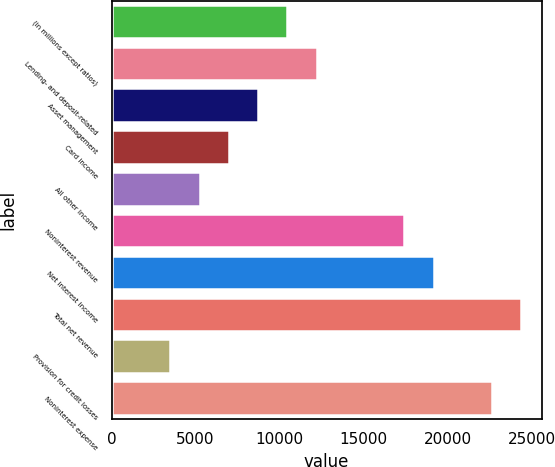<chart> <loc_0><loc_0><loc_500><loc_500><bar_chart><fcel>(in millions except ratios)<fcel>Lending- and deposit-related<fcel>Asset management<fcel>Card income<fcel>All other income<fcel>Noninterest revenue<fcel>Net interest income<fcel>Total net revenue<fcel>Provision for credit losses<fcel>Noninterest expense<nl><fcel>10457.6<fcel>12196.2<fcel>8719<fcel>6980.4<fcel>5241.8<fcel>17412<fcel>19150.6<fcel>24366.4<fcel>3503.2<fcel>22627.8<nl></chart> 